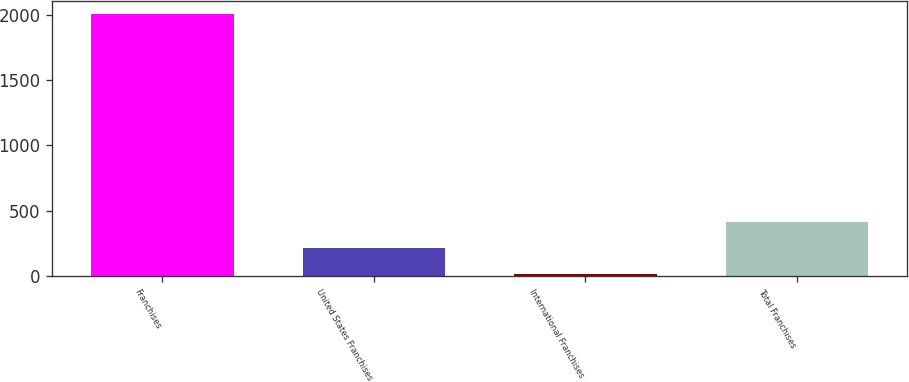Convert chart. <chart><loc_0><loc_0><loc_500><loc_500><bar_chart><fcel>Franchises<fcel>United States Franchises<fcel>International Franchises<fcel>Total Franchises<nl><fcel>2008<fcel>210.7<fcel>11<fcel>410.4<nl></chart> 